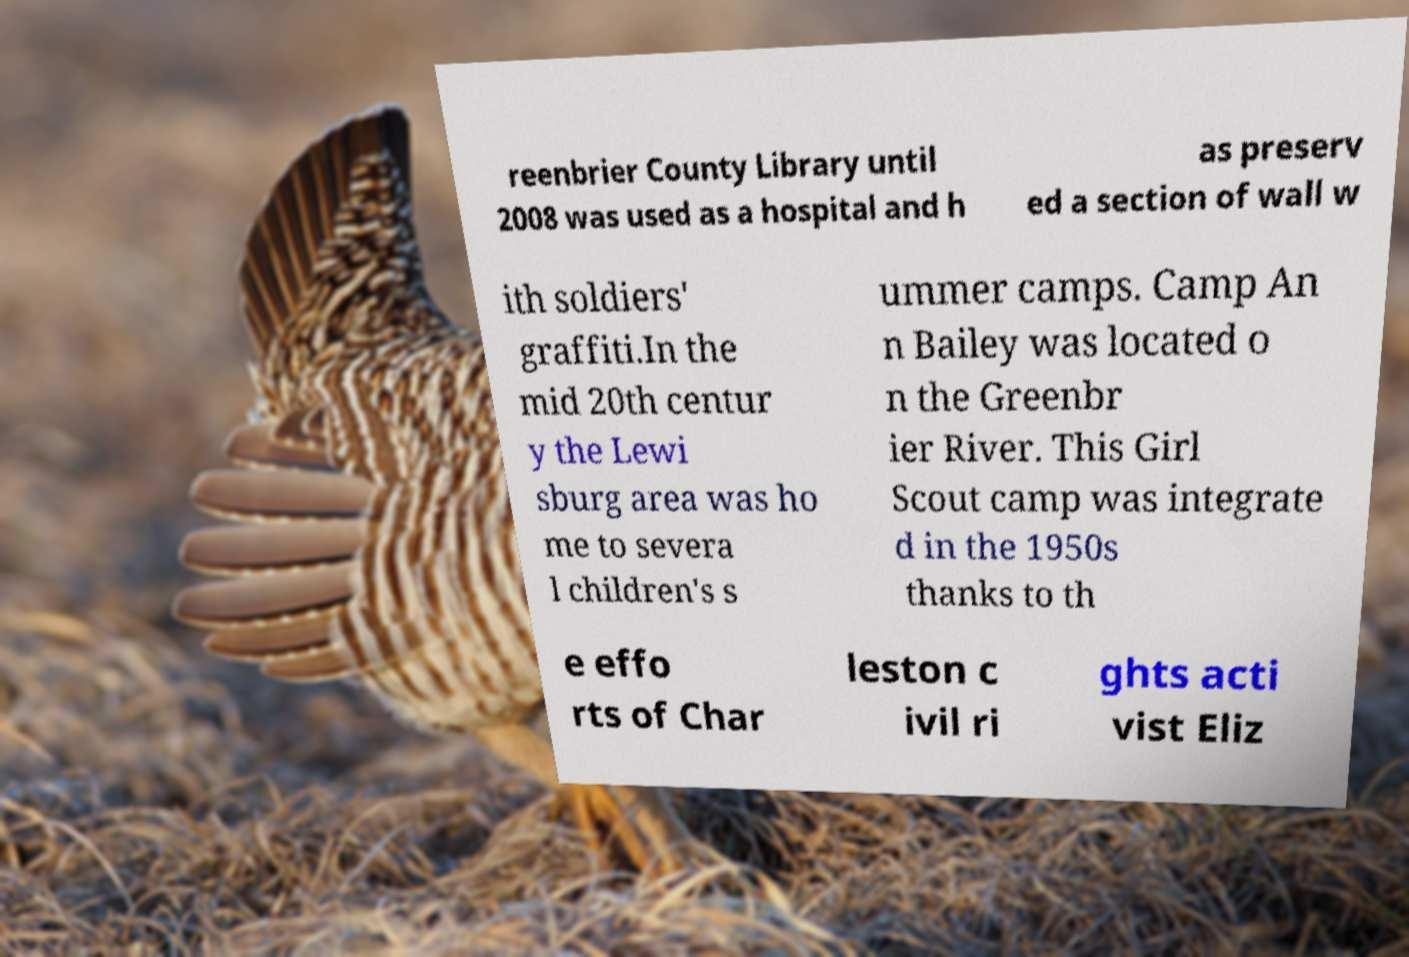Can you read and provide the text displayed in the image?This photo seems to have some interesting text. Can you extract and type it out for me? reenbrier County Library until 2008 was used as a hospital and h as preserv ed a section of wall w ith soldiers' graffiti.In the mid 20th centur y the Lewi sburg area was ho me to severa l children's s ummer camps. Camp An n Bailey was located o n the Greenbr ier River. This Girl Scout camp was integrate d in the 1950s thanks to th e effo rts of Char leston c ivil ri ghts acti vist Eliz 